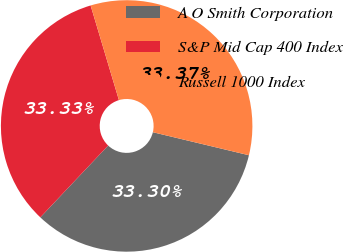<chart> <loc_0><loc_0><loc_500><loc_500><pie_chart><fcel>A O Smith Corporation<fcel>S&P Mid Cap 400 Index<fcel>Russell 1000 Index<nl><fcel>33.3%<fcel>33.33%<fcel>33.37%<nl></chart> 